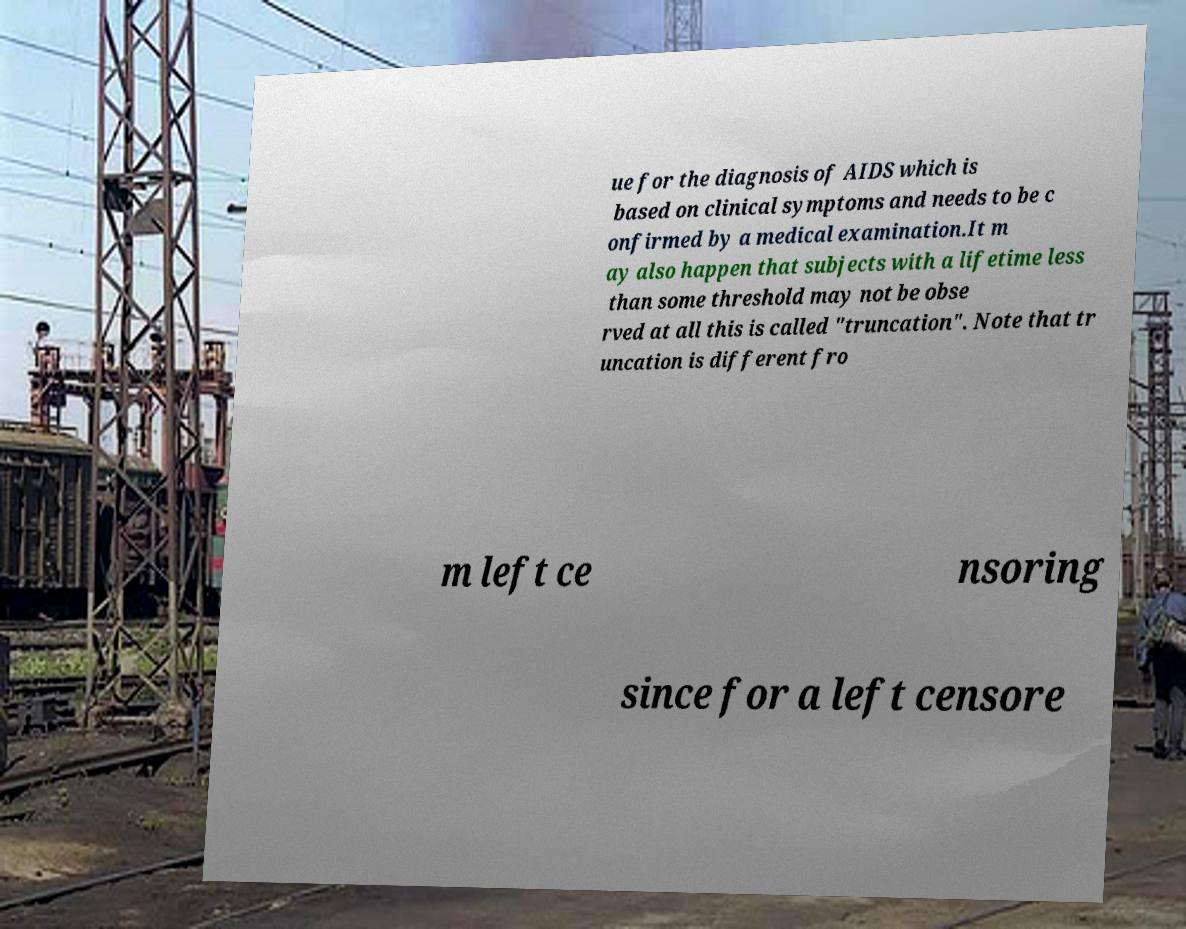Please read and relay the text visible in this image. What does it say? ue for the diagnosis of AIDS which is based on clinical symptoms and needs to be c onfirmed by a medical examination.It m ay also happen that subjects with a lifetime less than some threshold may not be obse rved at all this is called "truncation". Note that tr uncation is different fro m left ce nsoring since for a left censore 